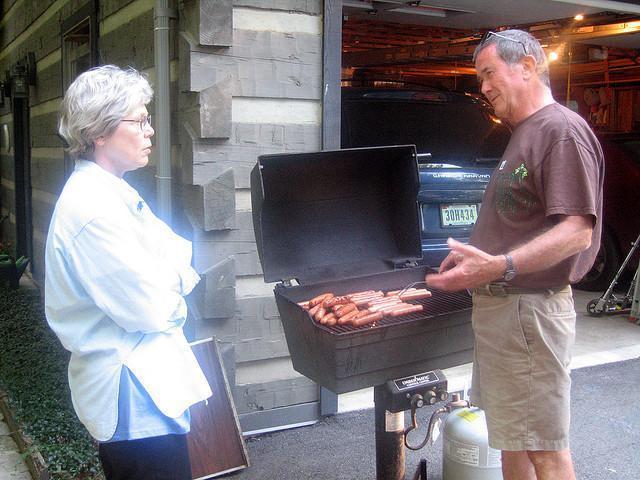How many people are in the picture?
Give a very brief answer. 2. 